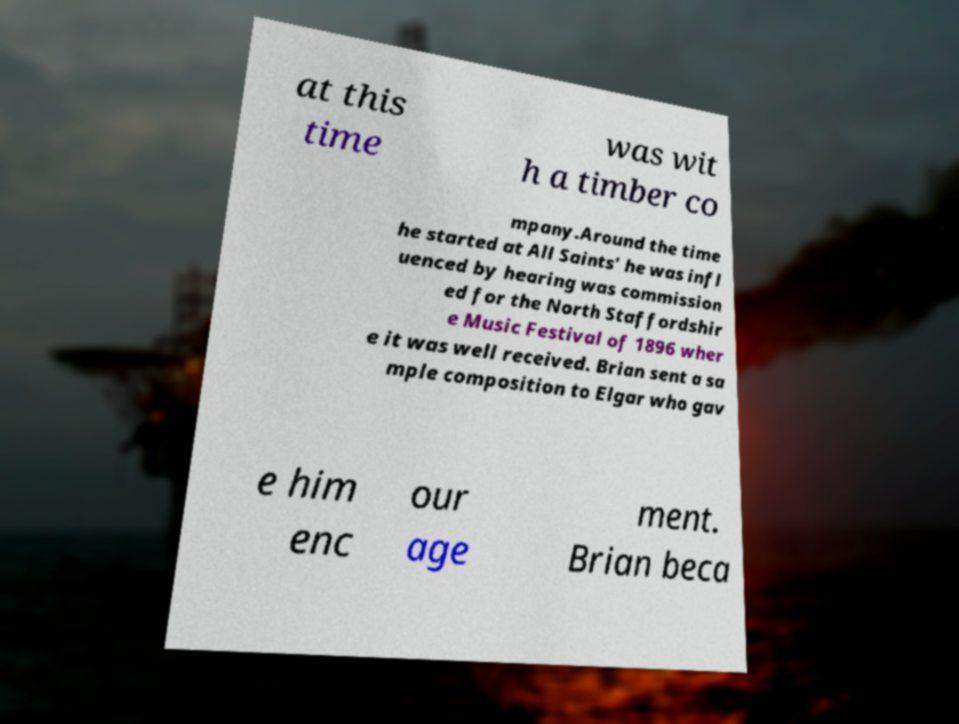There's text embedded in this image that I need extracted. Can you transcribe it verbatim? at this time was wit h a timber co mpany.Around the time he started at All Saints' he was infl uenced by hearing was commission ed for the North Staffordshir e Music Festival of 1896 wher e it was well received. Brian sent a sa mple composition to Elgar who gav e him enc our age ment. Brian beca 